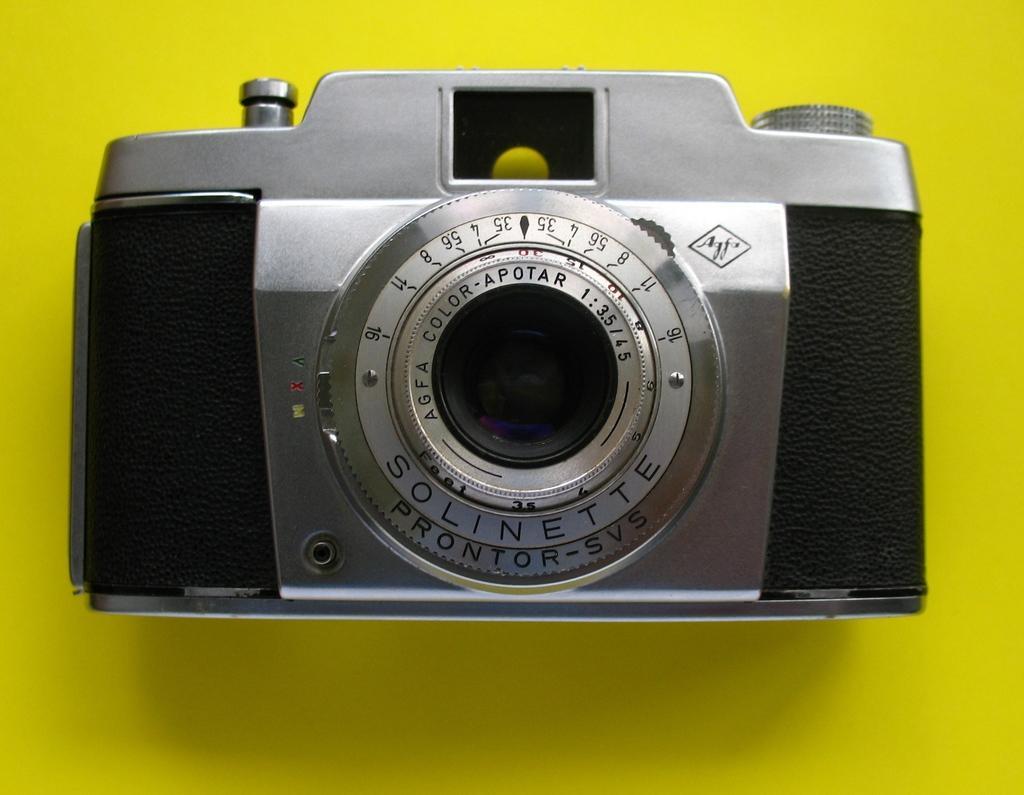Describe this image in one or two sentences. In the picture I can see a camera. The background of the image is yellow in color. 